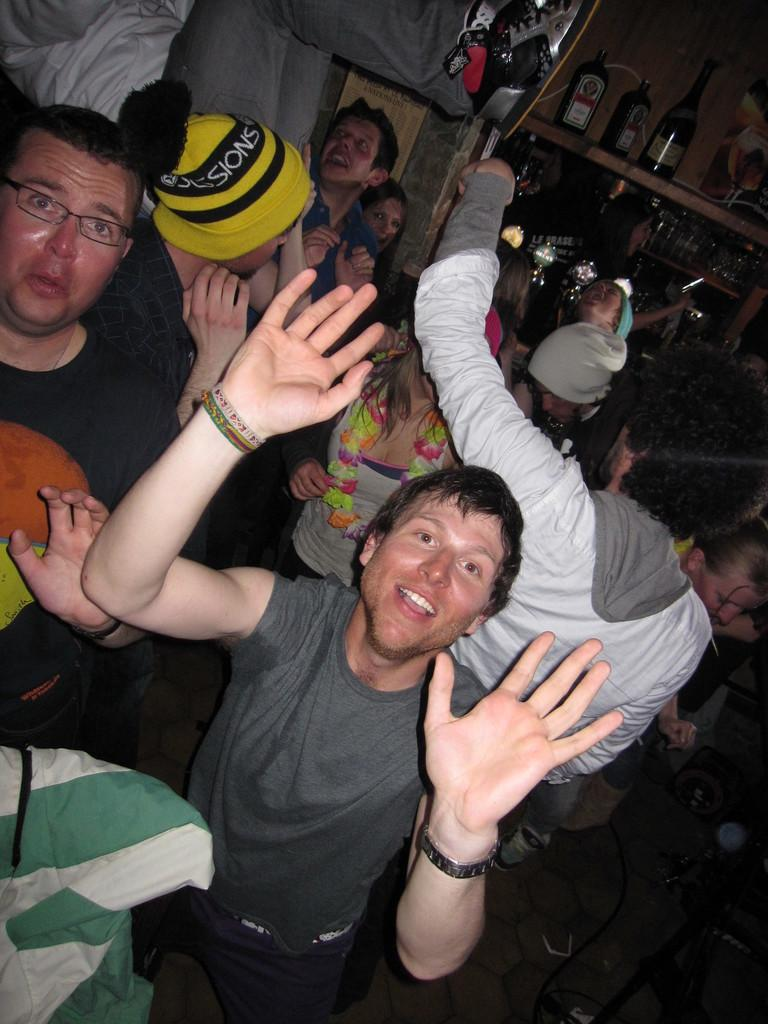What are the people in the image doing? There is a group of persons standing on the floor. Can you describe the appearance of one of the persons in the group? One person is wearing a yellow cap. What can be seen in the background of the image? There is a group of bottles in the background. How are the bottles arranged in the image? The bottles are placed on a rack. Where is the maid standing in the image? There is no maid present in the image. What type of loss is depicted in the image? There is no loss depicted in the image; it features a group of persons standing on the floor and a group of bottles on a rack. 